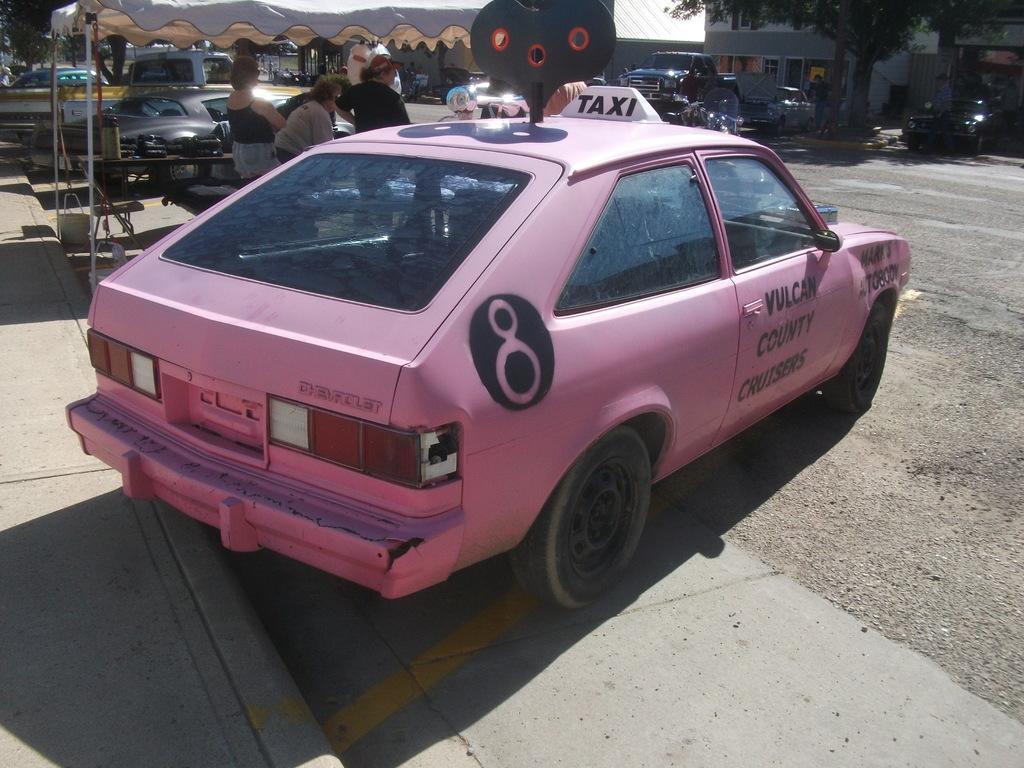Please provide a concise description of this image. As we can see in the image there are cars, buildings, tree and few people here and there. 